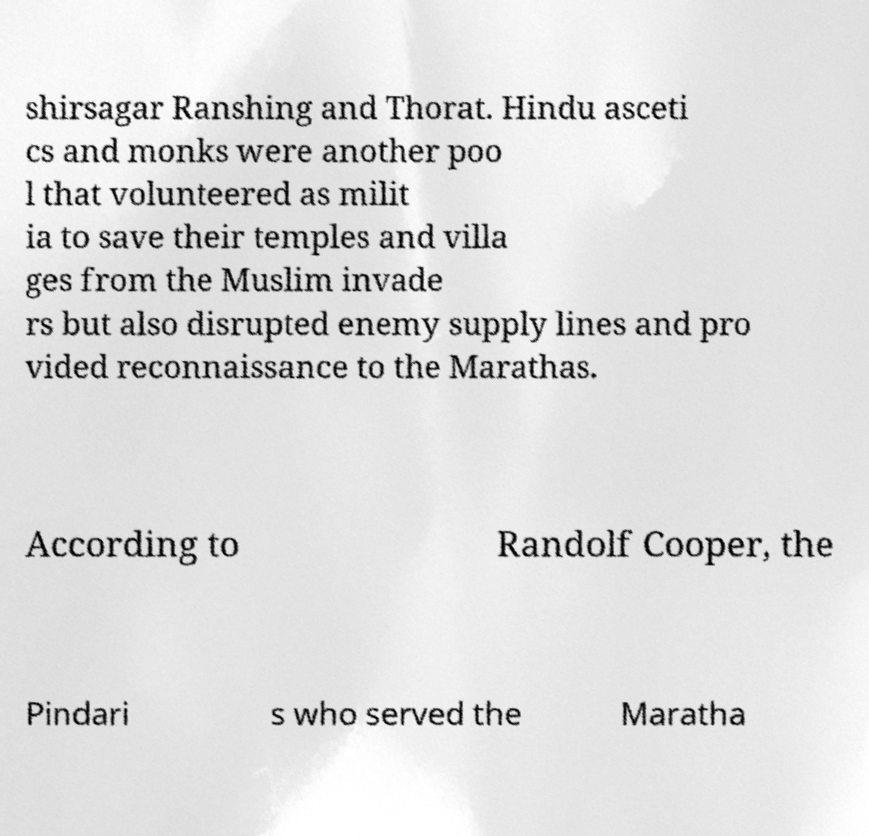I need the written content from this picture converted into text. Can you do that? shirsagar Ranshing and Thorat. Hindu asceti cs and monks were another poo l that volunteered as milit ia to save their temples and villa ges from the Muslim invade rs but also disrupted enemy supply lines and pro vided reconnaissance to the Marathas. According to Randolf Cooper, the Pindari s who served the Maratha 